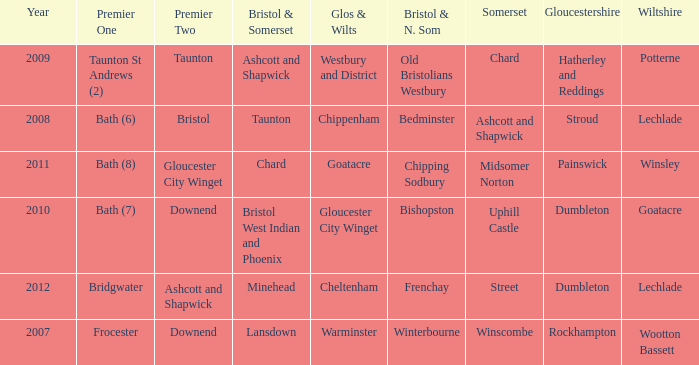Who many times is gloucestershire is painswick? 1.0. 